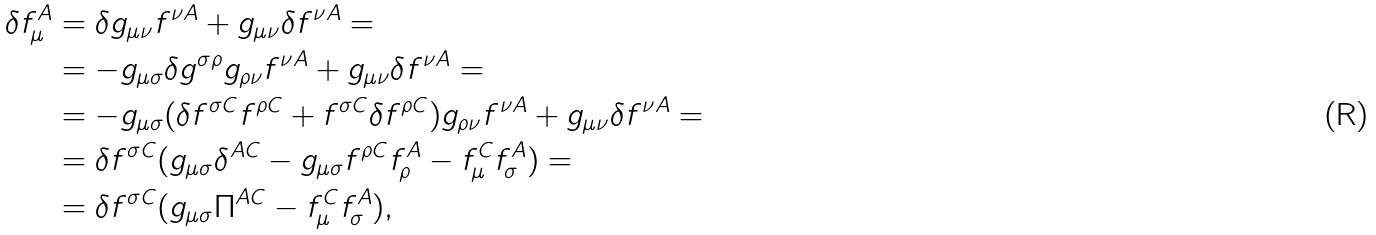<formula> <loc_0><loc_0><loc_500><loc_500>\delta f _ { \mu } ^ { A } & = \delta g _ { \mu \nu } f ^ { \nu A } + g _ { \mu \nu } \delta f ^ { \nu A } = \\ & = - g _ { \mu \sigma } \delta g ^ { \sigma \rho } g _ { \rho \nu } f ^ { \nu A } + g _ { \mu \nu } \delta f ^ { \nu A } = \\ & = - g _ { \mu \sigma } ( \delta f ^ { \sigma C } f ^ { \rho C } + f ^ { \sigma C } \delta f ^ { \rho C } ) g _ { \rho \nu } f ^ { \nu A } + g _ { \mu \nu } \delta f ^ { \nu A } = \\ & = \delta f ^ { \sigma C } ( g _ { \mu \sigma } \delta ^ { A C } - g _ { \mu \sigma } f ^ { \rho C } f _ { \rho } ^ { A } - f _ { \mu } ^ { C } f _ { \sigma } ^ { A } ) = \\ & = \delta f ^ { \sigma C } ( g _ { \mu \sigma } \Pi ^ { A C } - f _ { \mu } ^ { C } f _ { \sigma } ^ { A } ) ,</formula> 